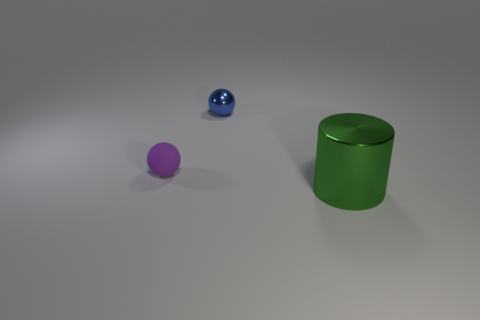Can you describe the textures and materials of the objects? Certainly! The sphere on the left seems to have a matte rubber texture, implying a soft and non-reflective surface. The blue sphere in the middle appears shiny and metallic, which suggests it has a reflective, smooth surface. Lastly, the green cylinder on the right also has a metallic finish, likely smooth to the touch and reflective. 